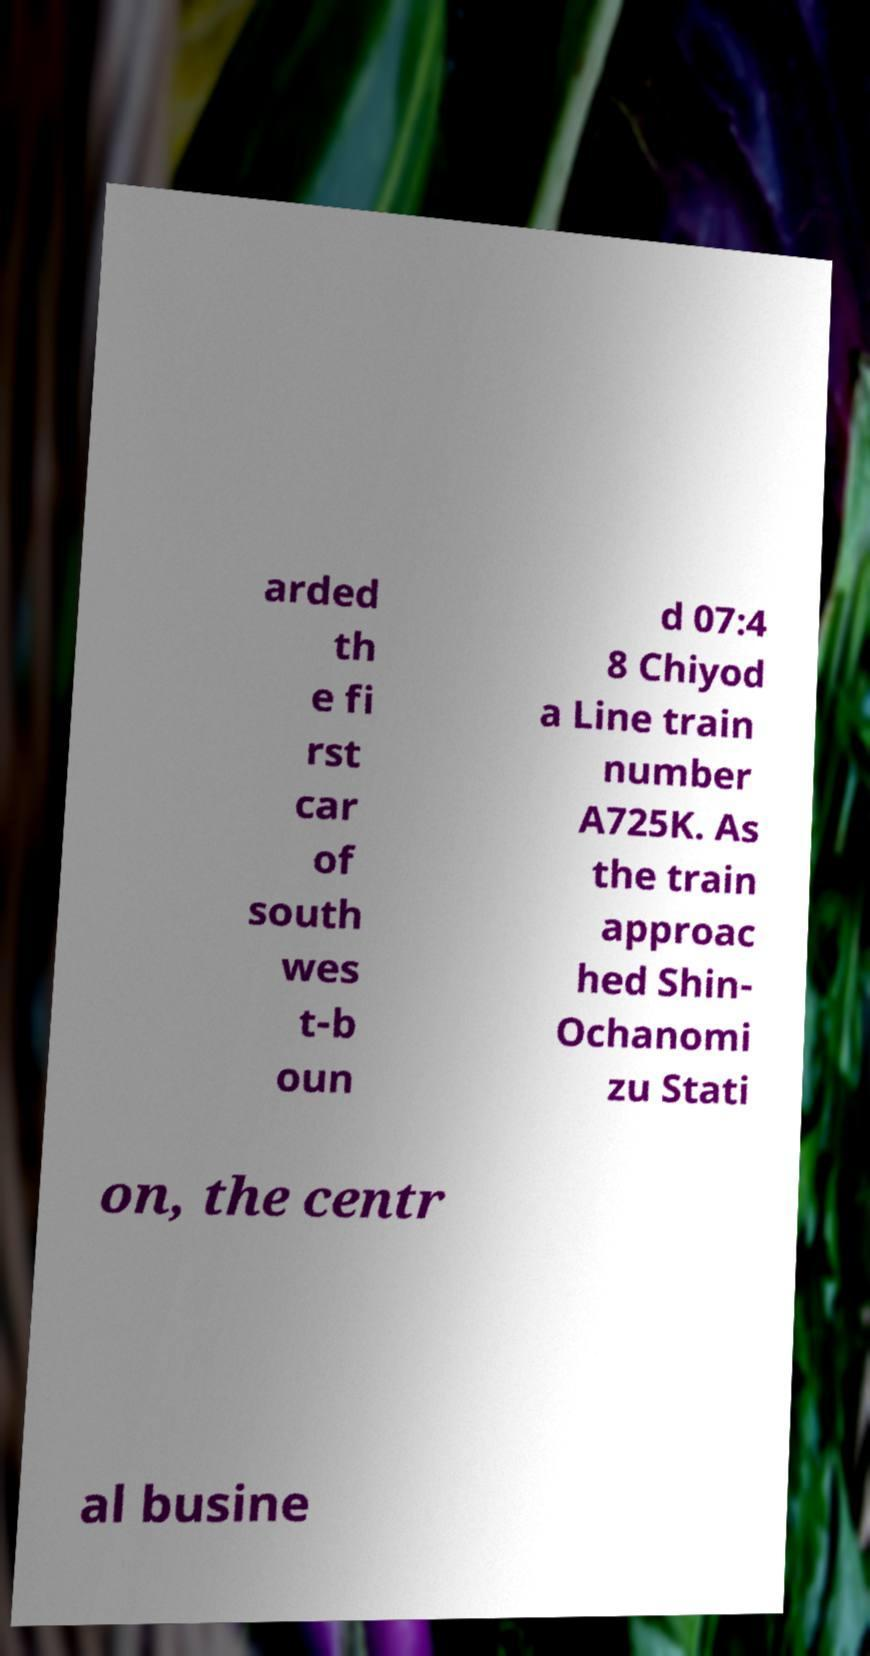Please identify and transcribe the text found in this image. arded th e fi rst car of south wes t-b oun d 07:4 8 Chiyod a Line train number A725K. As the train approac hed Shin- Ochanomi zu Stati on, the centr al busine 